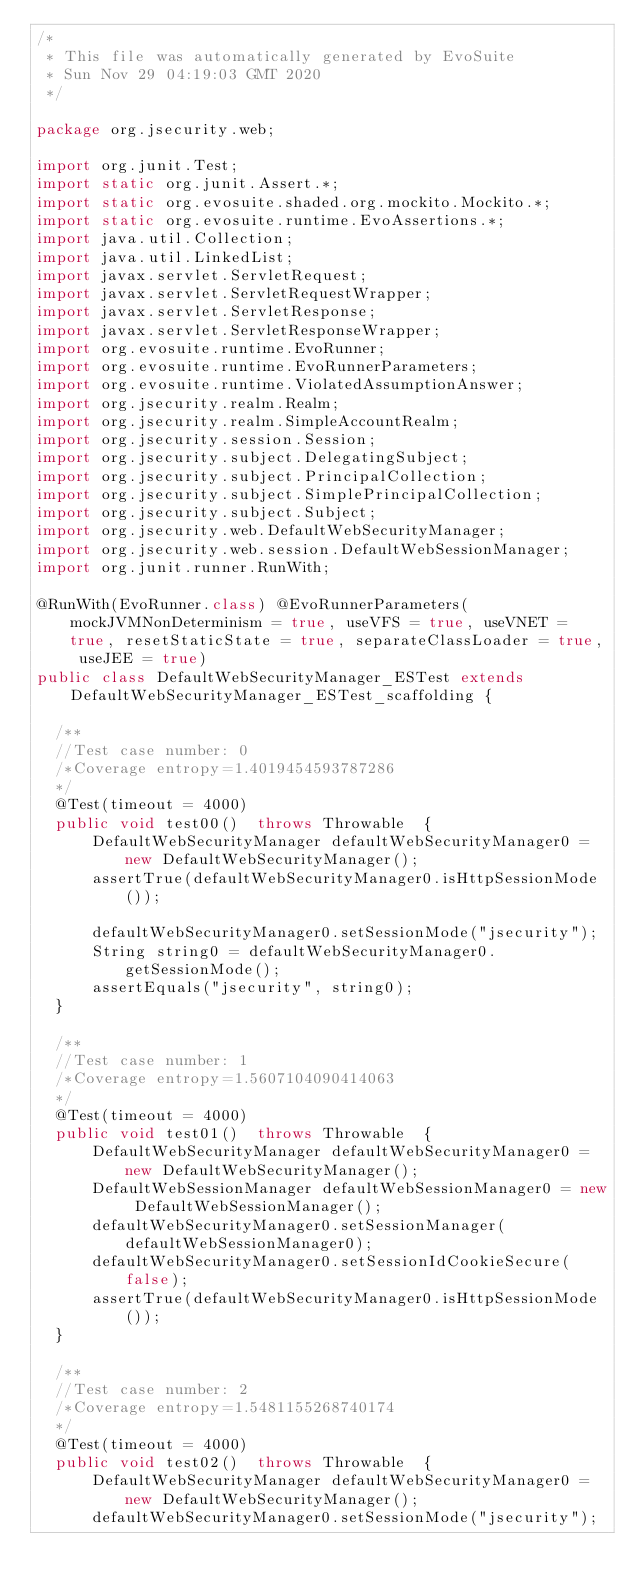<code> <loc_0><loc_0><loc_500><loc_500><_Java_>/*
 * This file was automatically generated by EvoSuite
 * Sun Nov 29 04:19:03 GMT 2020
 */

package org.jsecurity.web;

import org.junit.Test;
import static org.junit.Assert.*;
import static org.evosuite.shaded.org.mockito.Mockito.*;
import static org.evosuite.runtime.EvoAssertions.*;
import java.util.Collection;
import java.util.LinkedList;
import javax.servlet.ServletRequest;
import javax.servlet.ServletRequestWrapper;
import javax.servlet.ServletResponse;
import javax.servlet.ServletResponseWrapper;
import org.evosuite.runtime.EvoRunner;
import org.evosuite.runtime.EvoRunnerParameters;
import org.evosuite.runtime.ViolatedAssumptionAnswer;
import org.jsecurity.realm.Realm;
import org.jsecurity.realm.SimpleAccountRealm;
import org.jsecurity.session.Session;
import org.jsecurity.subject.DelegatingSubject;
import org.jsecurity.subject.PrincipalCollection;
import org.jsecurity.subject.SimplePrincipalCollection;
import org.jsecurity.subject.Subject;
import org.jsecurity.web.DefaultWebSecurityManager;
import org.jsecurity.web.session.DefaultWebSessionManager;
import org.junit.runner.RunWith;

@RunWith(EvoRunner.class) @EvoRunnerParameters(mockJVMNonDeterminism = true, useVFS = true, useVNET = true, resetStaticState = true, separateClassLoader = true, useJEE = true) 
public class DefaultWebSecurityManager_ESTest extends DefaultWebSecurityManager_ESTest_scaffolding {

  /**
  //Test case number: 0
  /*Coverage entropy=1.4019454593787286
  */
  @Test(timeout = 4000)
  public void test00()  throws Throwable  {
      DefaultWebSecurityManager defaultWebSecurityManager0 = new DefaultWebSecurityManager();
      assertTrue(defaultWebSecurityManager0.isHttpSessionMode());
      
      defaultWebSecurityManager0.setSessionMode("jsecurity");
      String string0 = defaultWebSecurityManager0.getSessionMode();
      assertEquals("jsecurity", string0);
  }

  /**
  //Test case number: 1
  /*Coverage entropy=1.5607104090414063
  */
  @Test(timeout = 4000)
  public void test01()  throws Throwable  {
      DefaultWebSecurityManager defaultWebSecurityManager0 = new DefaultWebSecurityManager();
      DefaultWebSessionManager defaultWebSessionManager0 = new DefaultWebSessionManager();
      defaultWebSecurityManager0.setSessionManager(defaultWebSessionManager0);
      defaultWebSecurityManager0.setSessionIdCookieSecure(false);
      assertTrue(defaultWebSecurityManager0.isHttpSessionMode());
  }

  /**
  //Test case number: 2
  /*Coverage entropy=1.5481155268740174
  */
  @Test(timeout = 4000)
  public void test02()  throws Throwable  {
      DefaultWebSecurityManager defaultWebSecurityManager0 = new DefaultWebSecurityManager();
      defaultWebSecurityManager0.setSessionMode("jsecurity");</code> 